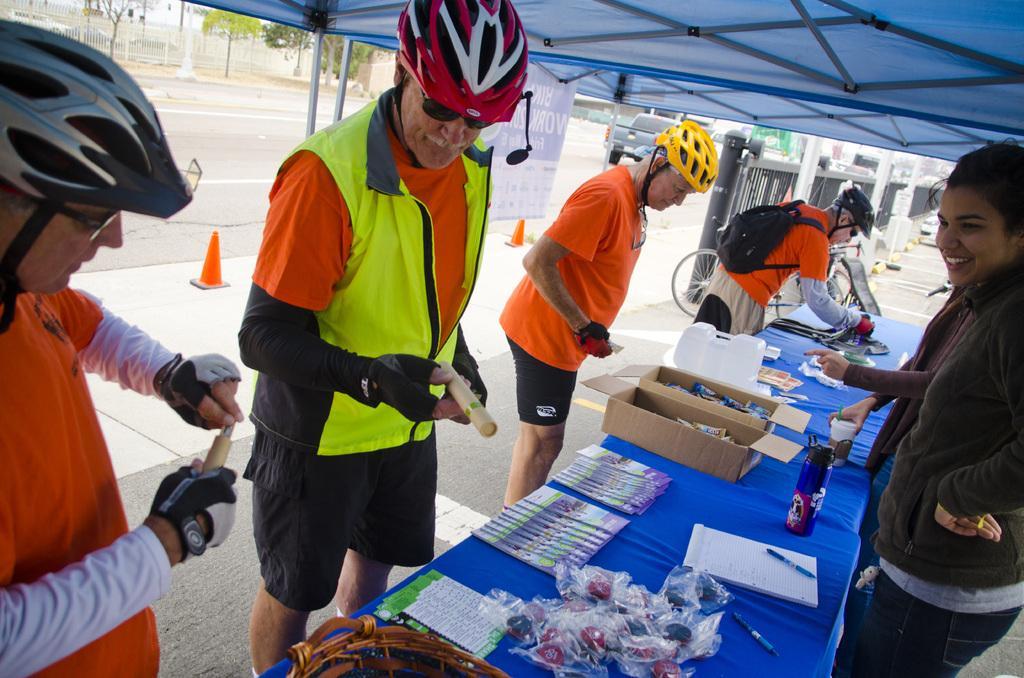In one or two sentences, can you explain what this image depicts? In this image we can see a few people standing near a table. There are many objects placed on the table. There are few cars parked in the image. There is a fencing, few orange color cones and a banner in the image. There are few plants in the image. There are few vehicles moving on the road. 